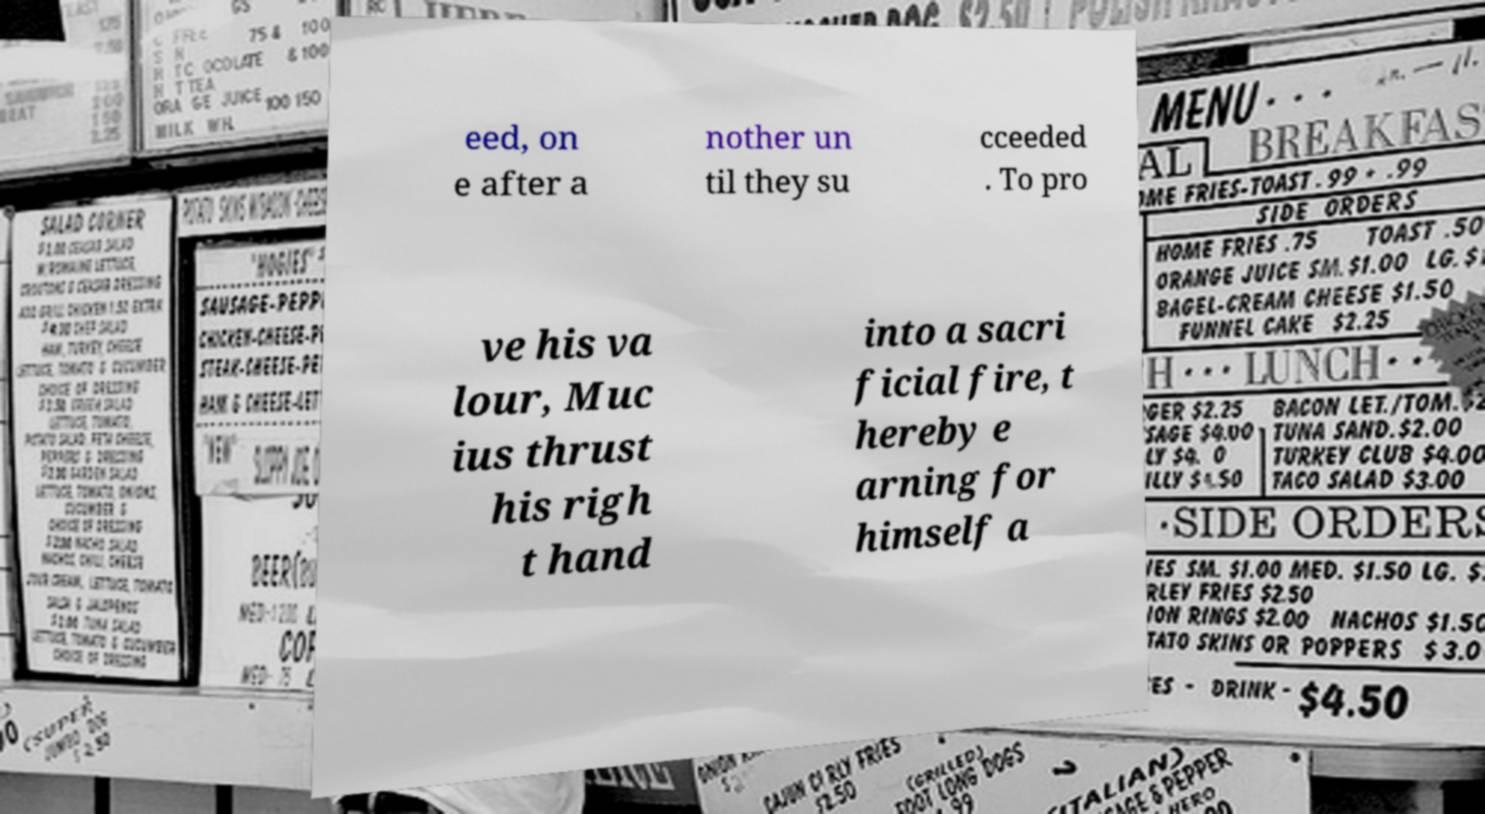Could you extract and type out the text from this image? eed, on e after a nother un til they su cceeded . To pro ve his va lour, Muc ius thrust his righ t hand into a sacri ficial fire, t hereby e arning for himself a 